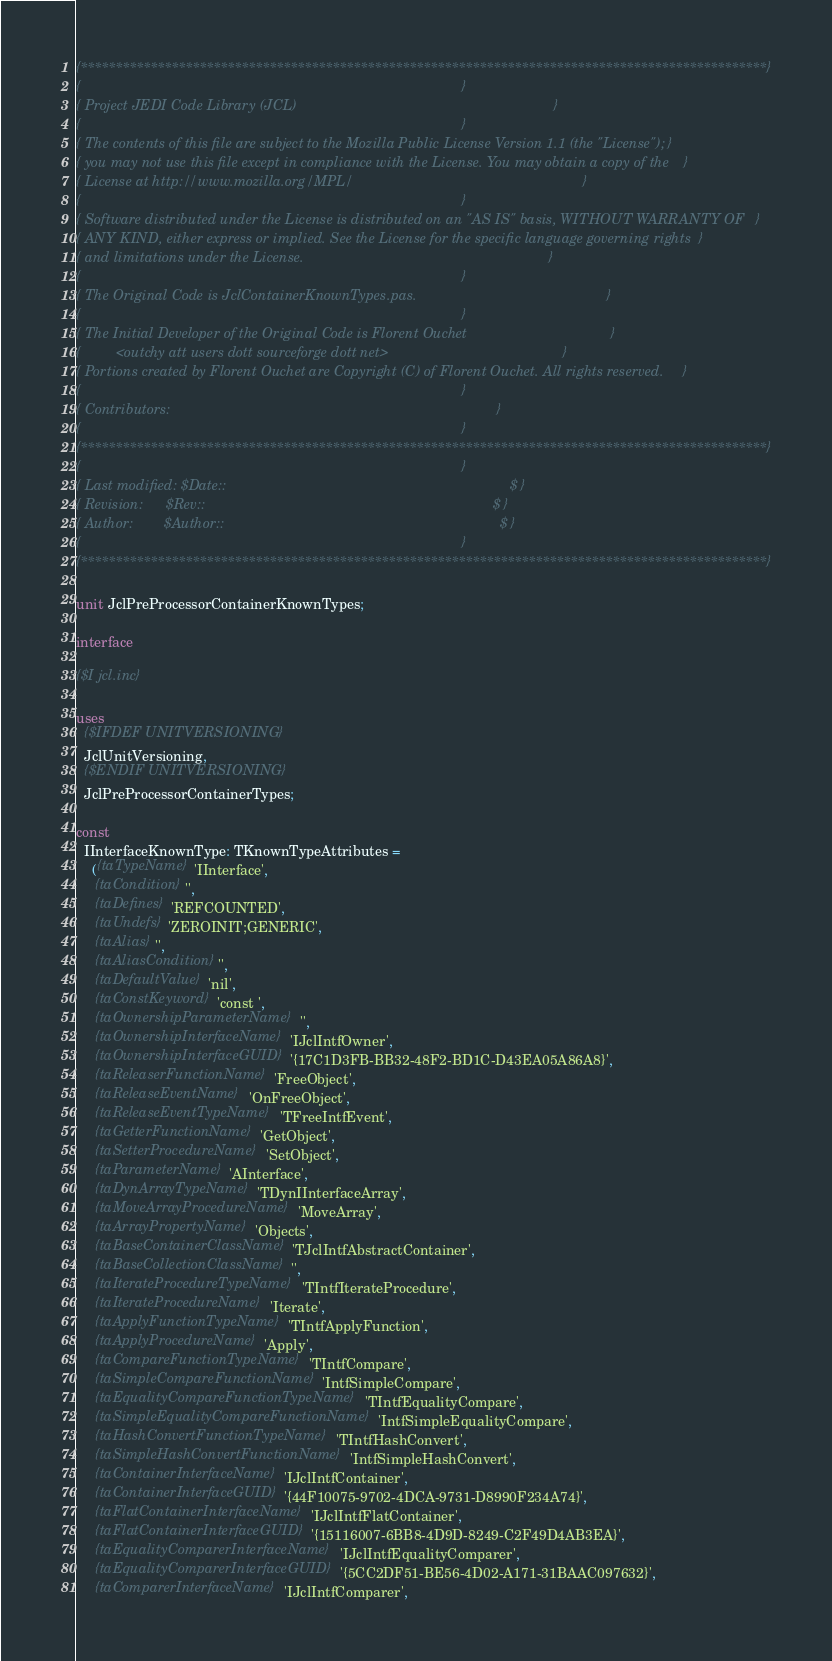<code> <loc_0><loc_0><loc_500><loc_500><_Pascal_>{**************************************************************************************************}
{                                                                                                  }
{ Project JEDI Code Library (JCL)                                                                  }
{                                                                                                  }
{ The contents of this file are subject to the Mozilla Public License Version 1.1 (the "License"); }
{ you may not use this file except in compliance with the License. You may obtain a copy of the    }
{ License at http://www.mozilla.org/MPL/                                                           }
{                                                                                                  }
{ Software distributed under the License is distributed on an "AS IS" basis, WITHOUT WARRANTY OF   }
{ ANY KIND, either express or implied. See the License for the specific language governing rights  }
{ and limitations under the License.                                                               }
{                                                                                                  }
{ The Original Code is JclContainerKnownTypes.pas.                                                 }
{                                                                                                  }
{ The Initial Developer of the Original Code is Florent Ouchet                                     }
{         <outchy att users dott sourceforge dott net>                                             }
{ Portions created by Florent Ouchet are Copyright (C) of Florent Ouchet. All rights reserved.     }
{                                                                                                  }
{ Contributors:                                                                                    }
{                                                                                                  }
{**************************************************************************************************}
{                                                                                                  }
{ Last modified: $Date::                                                                         $ }
{ Revision:      $Rev::                                                                          $ }
{ Author:        $Author::                                                                       $ }
{                                                                                                  }
{**************************************************************************************************}

unit JclPreProcessorContainerKnownTypes;

interface

{$I jcl.inc}

uses
  {$IFDEF UNITVERSIONING}
  JclUnitVersioning,
  {$ENDIF UNITVERSIONING}
  JclPreProcessorContainerTypes;

const
  IInterfaceKnownType: TKnownTypeAttributes =
    ({taTypeName} 'IInterface',
     {taCondition} '',
     {taDefines} 'REFCOUNTED',
     {taUndefs} 'ZEROINIT;GENERIC',
     {taAlias} '',
     {taAliasCondition} '',
     {taDefaultValue} 'nil',
     {taConstKeyword} 'const ',
     {taOwnershipParameterName} '',
     {taOwnershipInterfaceName} 'IJclIntfOwner',
     {taOwnershipInterfaceGUID} '{17C1D3FB-BB32-48F2-BD1C-D43EA05A86A8}',
     {taReleaserFunctionName} 'FreeObject',
     {taReleaseEventName} 'OnFreeObject',
     {taReleaseEventTypeName} 'TFreeIntfEvent',
     {taGetterFunctionName} 'GetObject',
     {taSetterProcedureName} 'SetObject',
     {taParameterName} 'AInterface',
     {taDynArrayTypeName} 'TDynIInterfaceArray',
     {taMoveArrayProcedureName} 'MoveArray',
     {taArrayPropertyName} 'Objects',
     {taBaseContainerClassName} 'TJclIntfAbstractContainer',
     {taBaseCollectionClassName} '',
     {taIterateProcedureTypeName} 'TIntfIterateProcedure',
     {taIterateProcedureName} 'Iterate',
     {taApplyFunctionTypeName} 'TIntfApplyFunction',
     {taApplyProcedureName} 'Apply',
     {taCompareFunctionTypeName} 'TIntfCompare',
     {taSimpleCompareFunctionName} 'IntfSimpleCompare',
     {taEqualityCompareFunctionTypeName} 'TIntfEqualityCompare',
     {taSimpleEqualityCompareFunctionName} 'IntfSimpleEqualityCompare',
     {taHashConvertFunctionTypeName} 'TIntfHashConvert',
     {taSimpleHashConvertFunctionName} 'IntfSimpleHashConvert',
     {taContainerInterfaceName} 'IJclIntfContainer',
     {taContainerInterfaceGUID} '{44F10075-9702-4DCA-9731-D8990F234A74}',
     {taFlatContainerInterfaceName} 'IJclIntfFlatContainer',
     {taFlatContainerInterfaceGUID} '{15116007-6BB8-4D9D-8249-C2F49D4AB3EA}',
     {taEqualityComparerInterfaceName} 'IJclIntfEqualityComparer',
     {taEqualityComparerInterfaceGUID} '{5CC2DF51-BE56-4D02-A171-31BAAC097632}',
     {taComparerInterfaceName} 'IJclIntfComparer',</code> 